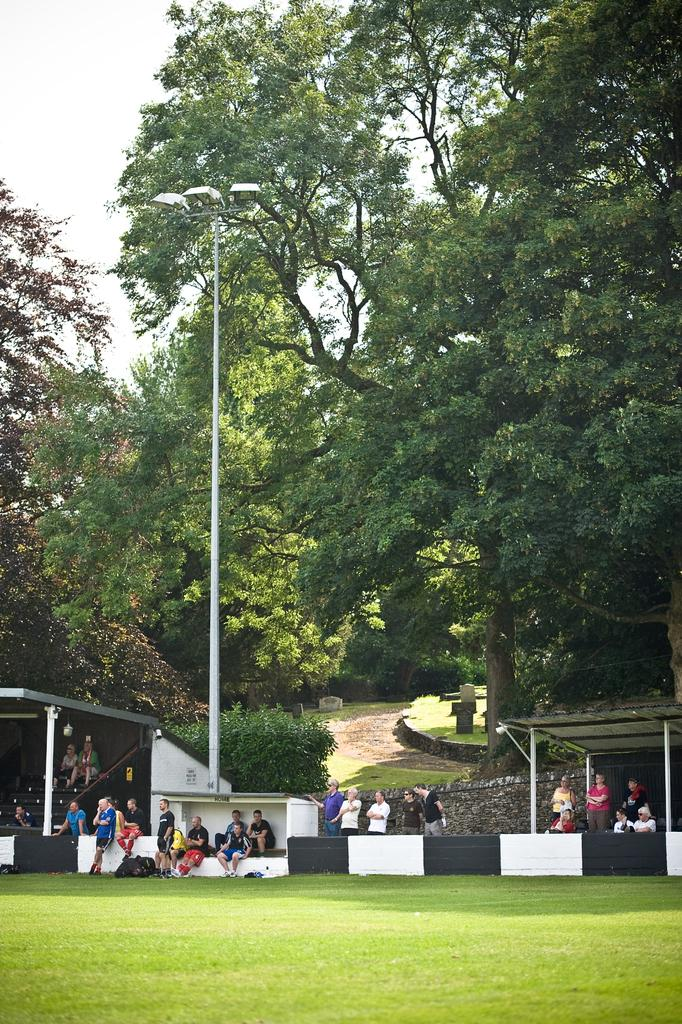What can be seen at the base of the image? The ground is visible in the image. Who or what is present in the image? There are people in the image. What type of structures can be seen in the image? There are shelters in the image. What type of vegetation is present in the image? Trees are present in the image. What is the tall, man-made object in the image? There is an electric pole in the image. What is visible in the background of the image? The sky is visible in the background of the image. What type of cheese is being used to build the shelters in the image? There is no cheese present in the image; the shelters are likely made of other materials. What authority figure can be seen directing the people in the image? There is no authority figure mentioned or visible in the image. 